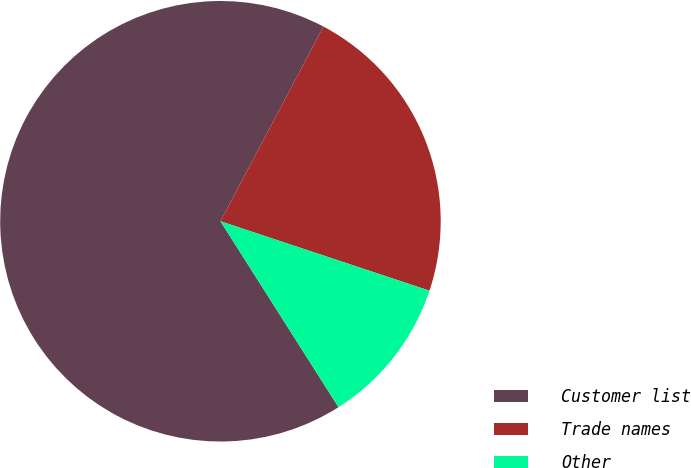Convert chart. <chart><loc_0><loc_0><loc_500><loc_500><pie_chart><fcel>Customer list<fcel>Trade names<fcel>Other<nl><fcel>66.75%<fcel>22.36%<fcel>10.89%<nl></chart> 